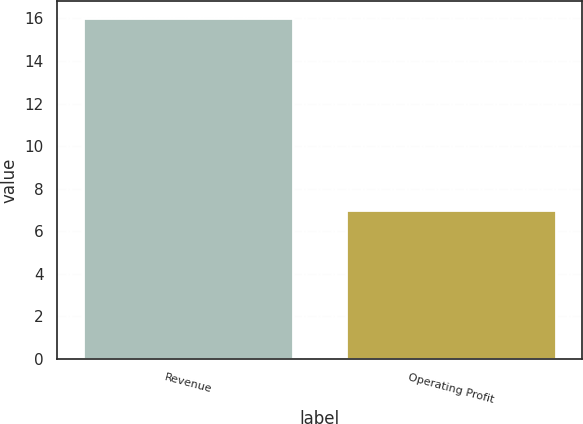<chart> <loc_0><loc_0><loc_500><loc_500><bar_chart><fcel>Revenue<fcel>Operating Profit<nl><fcel>16<fcel>7<nl></chart> 